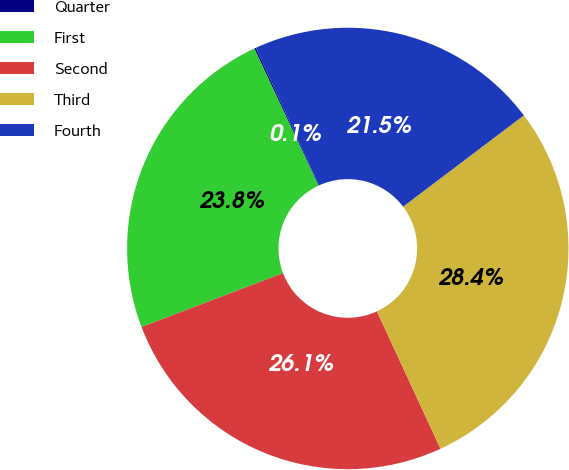Convert chart. <chart><loc_0><loc_0><loc_500><loc_500><pie_chart><fcel>Quarter<fcel>First<fcel>Second<fcel>Third<fcel>Fourth<nl><fcel>0.12%<fcel>23.83%<fcel>26.11%<fcel>28.4%<fcel>21.54%<nl></chart> 